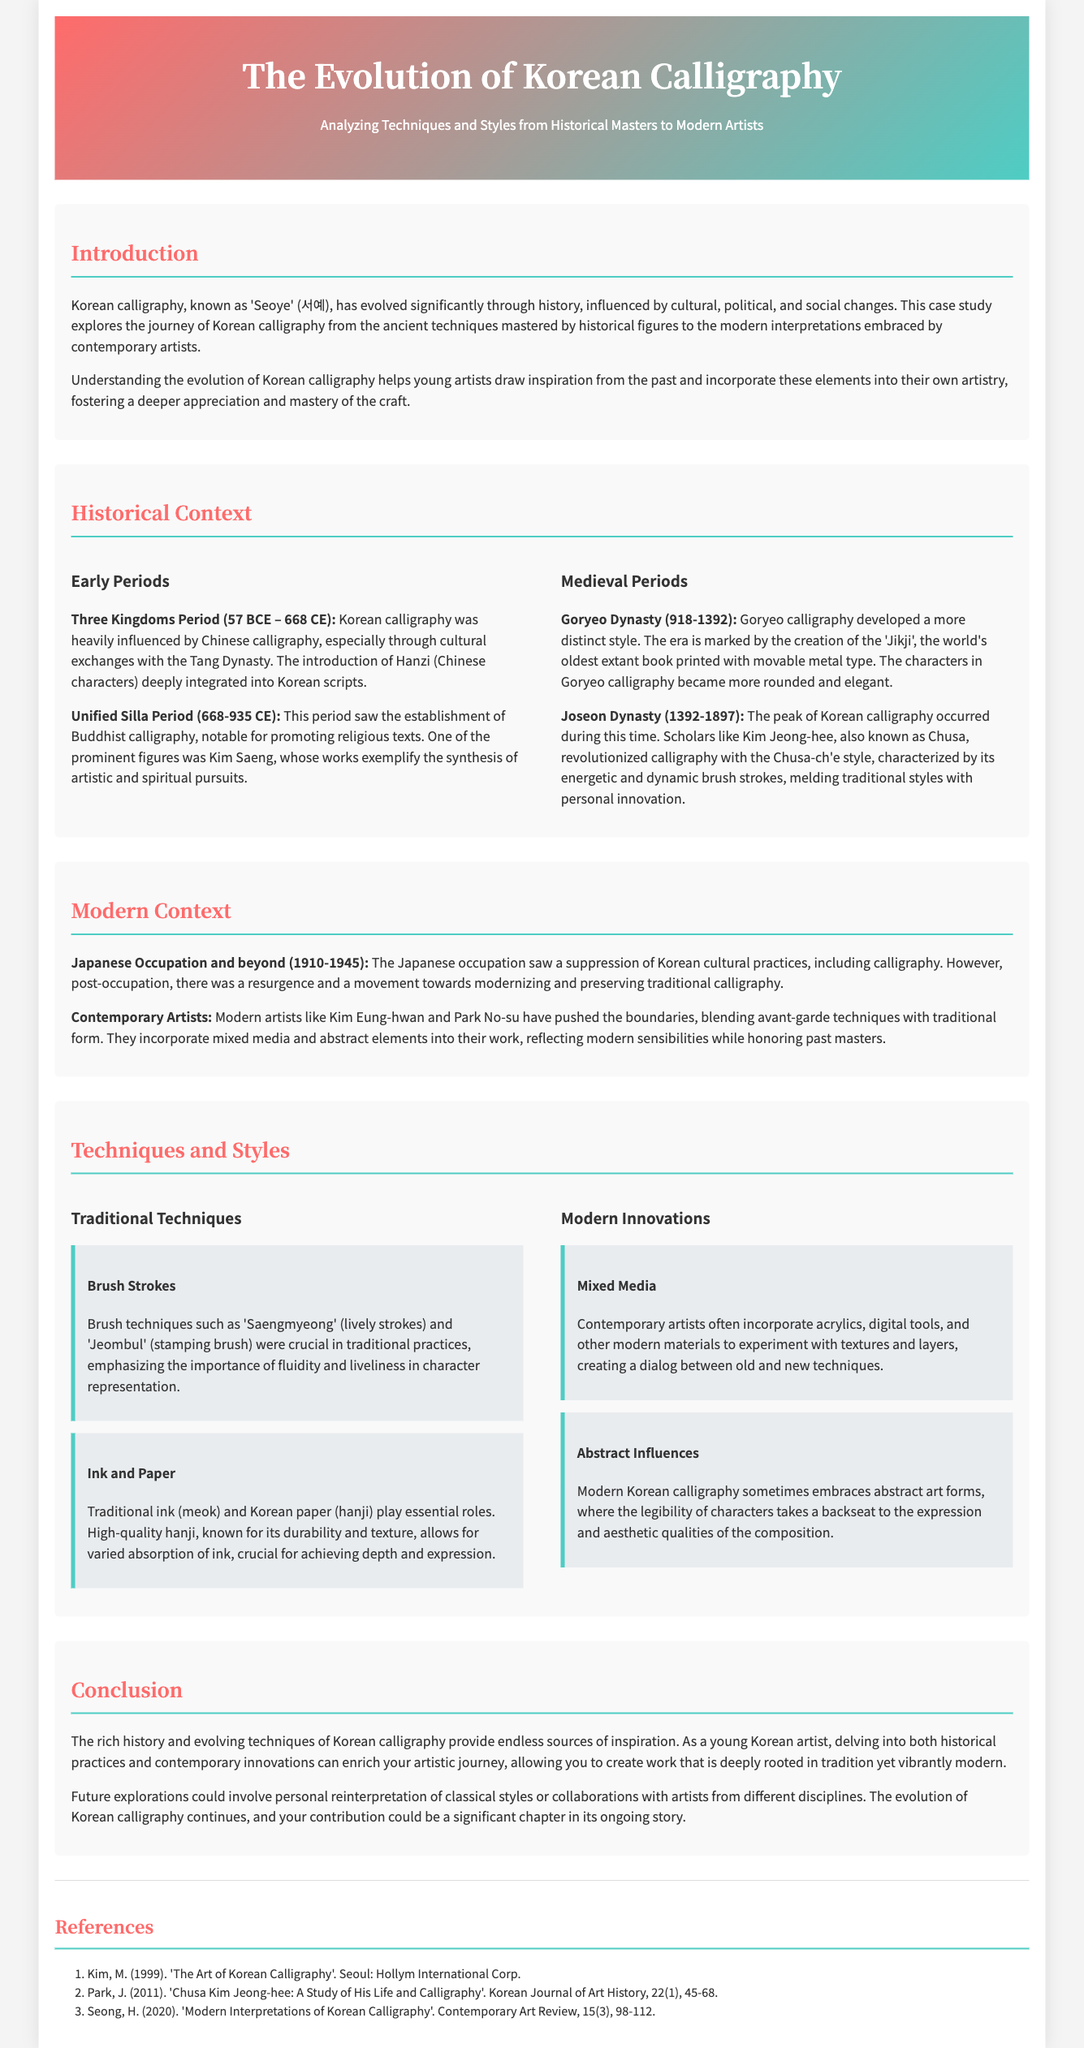What is the Korean term for calligraphy? The term for Korean calligraphy is mentioned as 'Seoye' (서예) in the document.
Answer: 'Seoye' (서예) Who is known as Chusa? The document mentions Kim Jeong-hee as Chusa, a notable scholar of the Joseon Dynasty.
Answer: Kim Jeong-hee During which period was the 'Jikji' created? The document states that the 'Jikji' was created during the Goryeo Dynasty (918-1392).
Answer: Goryeo Dynasty What modern materials do contemporary artists incorporate? The section on modern innovations lists acrylics and digital tools as materials used by modern artists.
Answer: Acrylics, digital tools What style is characterized by energetic brush strokes? The Chusa-ch'e style, created by Kim Jeong-hee, is noted for its dynamic brush strokes.
Answer: Chusa-ch'e style What was emphasized through traditional brush techniques? The document describes traditional brush techniques as emphasizing fluidity and liveliness in character representation.
Answer: Fluidity and liveliness Which period involved a suppression of Korean cultural practices? The document indicates the Japanese occupation (1910-1945) as a time of suppression of cultural practices.
Answer: Japanese occupation Who are two modern artists mentioned? Kim Eung-hwan and Park No-su are contemporary artists highlighted in the document.
Answer: Kim Eung-hwan, Park No-su What is one way the evolution of calligraphy can inspire young artists? The document states that understanding historical practices can help young artists incorporate past elements into their own artistry.
Answer: Incorporate past elements 